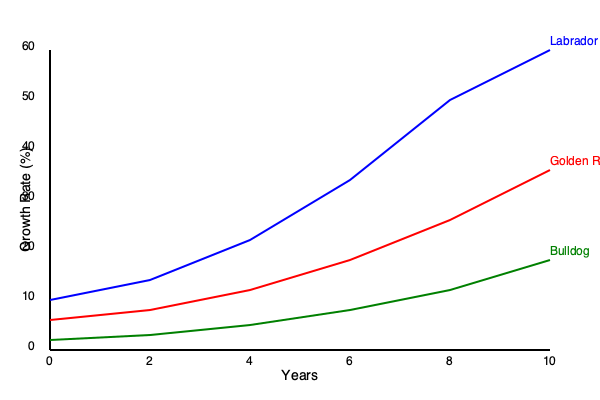The line graph shows the growth rates of three popular dog breeds over a 10-year period. Calculate the average rate of change in growth rate for the Labrador breed between years 4 and 8. Express your answer as a percentage per year, rounded to two decimal places. To calculate the average rate of change in growth rate for the Labrador breed between years 4 and 8, we'll follow these steps:

1. Identify the growth rates at years 4 and 8:
   - Year 4 (x₁ = 4): y₁ ≈ 24%
   - Year 8 (x₂ = 8): y₂ ≈ 50%

2. Calculate the change in growth rate:
   Δy = y₂ - y₁ = 50% - 24% = 26%

3. Calculate the change in time:
   Δx = x₂ - x₁ = 8 - 4 = 4 years

4. Apply the average rate of change formula:
   Average rate of change = Δy / Δx
   = 26% / 4 years
   = 6.5% per year

Therefore, the average rate of change in growth rate for the Labrador breed between years 4 and 8 is 6.5% per year.

To express this mathematically:

$$ \text{Average rate of change} = \frac{\Delta y}{\Delta x} = \frac{y_2 - y_1}{x_2 - x_1} = \frac{50\% - 24\%}{8 - 4} = \frac{26\%}{4} = 6.5\% \text{ per year} $$
Answer: 6.5% per year 